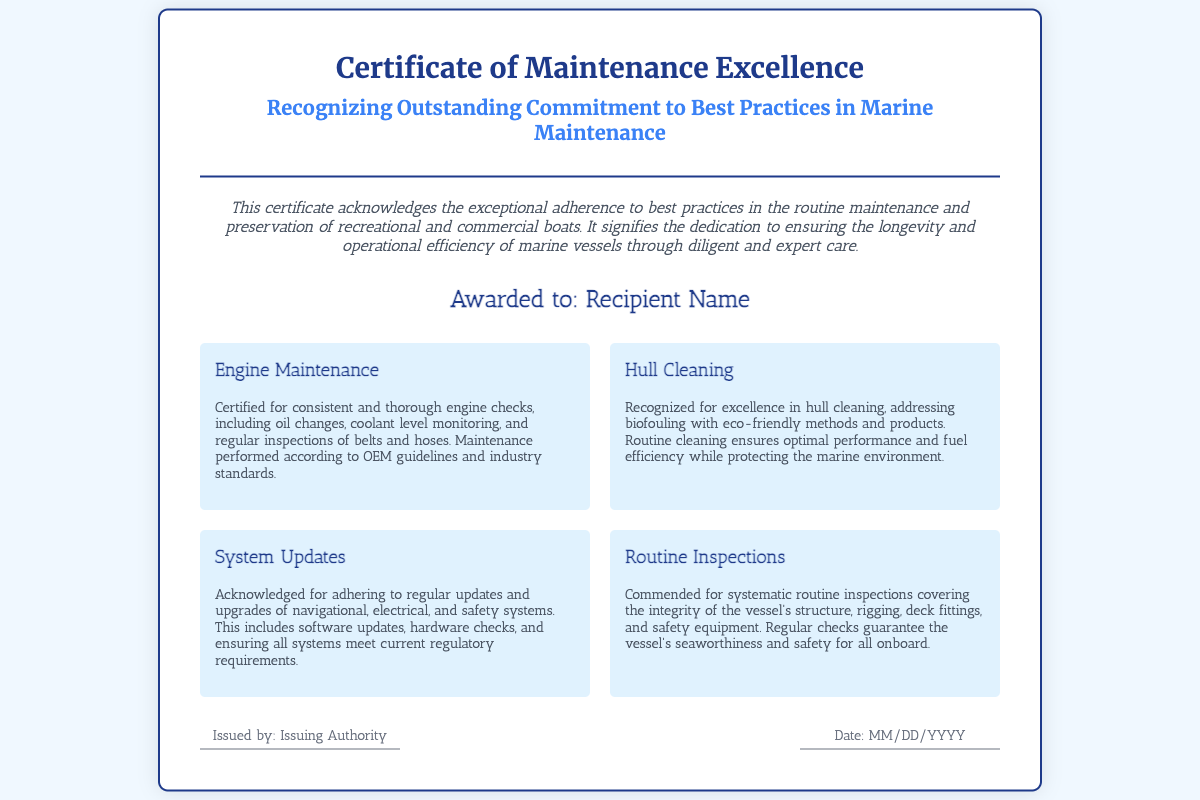What is the title of the document? The title of the document is prominently displayed at the top of the certificate.
Answer: Certificate of Maintenance Excellence Who is the certificate awarded to? The name of the recipient is indicated in the designated area on the certificate.
Answer: Recipient Name What are the four sections listed on the certificate? The sections cover key areas of maintenance recognized in the document.
Answer: Engine Maintenance, Hull Cleaning, System Updates, Routine Inspections What is the purpose of this certificate? The introduction states the main purpose of the certificate.
Answer: Recognizes adherence to best practices in maintenance What color is the border of the certificate? The color of the border can be inferred from the CSS styles applied to the document.
Answer: Dark blue Who issues the certificate? The issuing authority is mentioned in the footer section of the certificate.
Answer: Issuing Authority What date is indicated on the certificate? The issue date section is where the date would be noted on the document.
Answer: MM/DD/YYYY What does the footer of the certificate contain? The footer includes information about the issuer and date, as outlined in the document structure.
Answer: Issuer and Date What type of maintenance is certified for engine checks? The type of maintenance covered is specified in the relevant section of the document.
Answer: OEM guidelines and industry standards 